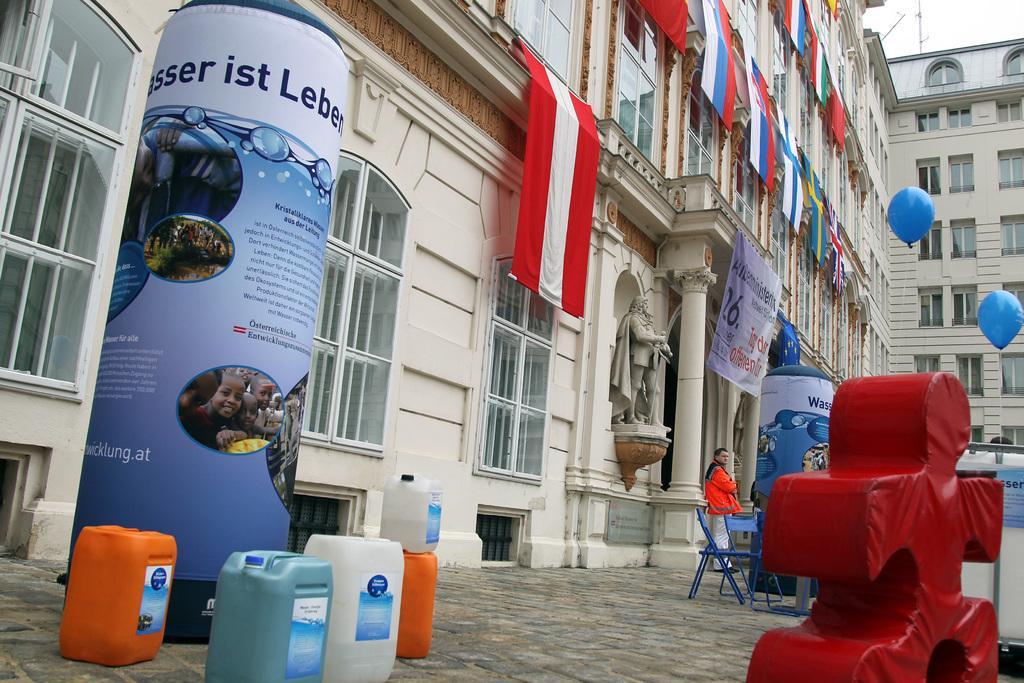How would you summarize this image in a sentence or two? In this image here there are few bottles. These are poles with pictures and texts. These are balloons. In the background there is a building. These are flags. Here a person is there. This is a statue. 